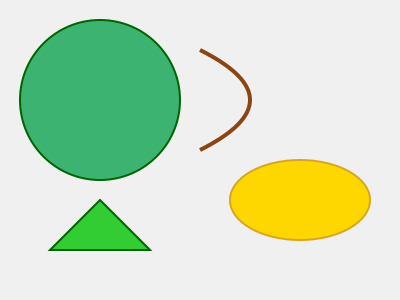Analyze the textures represented in the image and explain how you would incorporate these into a painting to depict the diverse tropical flora of the Philippines. Which traditional Filipino painting techniques could be employed to enhance the textural representation? 1. Identify the textures:
   a. Smooth, rounded surface (green circle)
   b. Rough, irregular line (brown curved line)
   c. Mottled, grainy surface (yellow oval)
   d. Sharp, angular shape (green triangle)

2. Relate textures to Filipino flora:
   a. Smooth texture: Represents leaves of banana trees or taro plants
   b. Rough texture: Depicts tree bark or coconut husks
   c. Mottled texture: Illustrates the skin of tropical fruits like mango or jackfruit
   d. Angular texture: Represents sharp leaves of pineapple plants or nipa palms

3. Incorporate textures into painting:
   a. Use layering techniques to build up smooth surfaces
   b. Apply impasto technique for rough textures
   c. Utilize stippling or dry brush techniques for mottled surfaces
   d. Employ sharp brushstrokes or palette knife for angular textures

4. Traditional Filipino painting techniques:
   a. Damián Domingo's costumbrismo style: Detailed representation of everyday life and nature
   b. Fernando Amorsolo's luminous technique: Use of light and shadow to enhance texture
   c. Vicente Manansala's transparent cubism: Overlapping planes to create depth and texture
   d. Ang Kiukok's expressionist approach: Bold brushstrokes and vibrant colors to emphasize texture

5. Enhance textural representation:
   a. Combine traditional techniques with modern materials (e.g., adding sand or organic matter to paint)
   b. Experiment with various tools beyond brushes (e.g., sponges, leaves, or local fibers)
   c. Incorporate indigenous materials like abaca fibers or bamboo for added texture
   d. Use chiaroscuro technique to highlight textural contrasts

By integrating these textures and techniques, the painting would effectively capture the essence of Philippine tropical flora while showcasing the rich artistic heritage of the country.
Answer: Layering, impasto, stippling, and sharp brushstrokes for diverse textures; incorporate traditional Filipino techniques like costumbrismo, luminous technique, transparent cubism, and expressionism; enhance with local materials and chiaroscuro. 